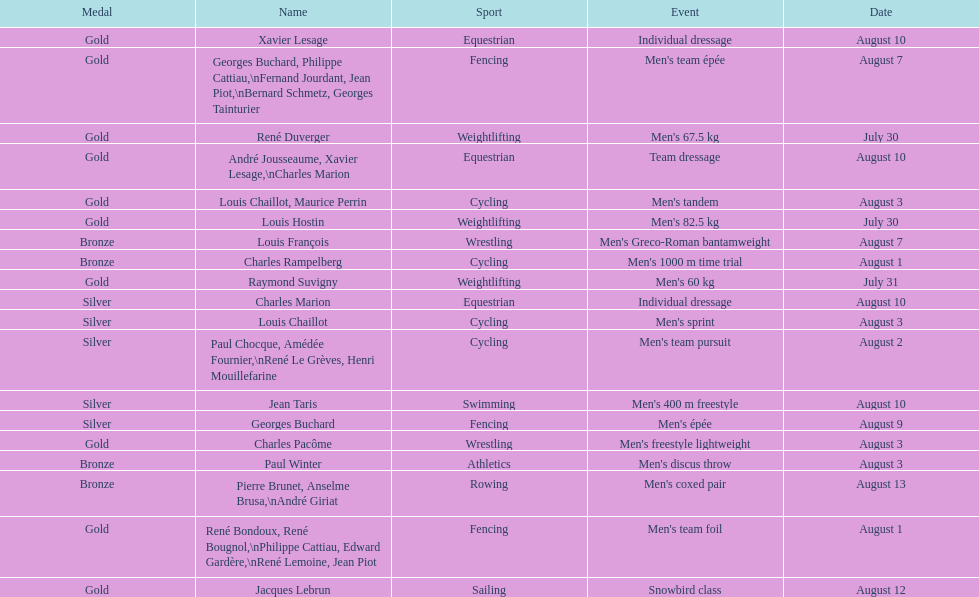Help me parse the entirety of this table. {'header': ['Medal', 'Name', 'Sport', 'Event', 'Date'], 'rows': [['Gold', 'Xavier Lesage', 'Equestrian', 'Individual dressage', 'August 10'], ['Gold', 'Georges Buchard, Philippe Cattiau,\\nFernand Jourdant, Jean Piot,\\nBernard Schmetz, Georges Tainturier', 'Fencing', "Men's team épée", 'August 7'], ['Gold', 'René Duverger', 'Weightlifting', "Men's 67.5 kg", 'July 30'], ['Gold', 'André Jousseaume, Xavier Lesage,\\nCharles Marion', 'Equestrian', 'Team dressage', 'August 10'], ['Gold', 'Louis Chaillot, Maurice Perrin', 'Cycling', "Men's tandem", 'August 3'], ['Gold', 'Louis Hostin', 'Weightlifting', "Men's 82.5 kg", 'July 30'], ['Bronze', 'Louis François', 'Wrestling', "Men's Greco-Roman bantamweight", 'August 7'], ['Bronze', 'Charles Rampelberg', 'Cycling', "Men's 1000 m time trial", 'August 1'], ['Gold', 'Raymond Suvigny', 'Weightlifting', "Men's 60 kg", 'July 31'], ['Silver', 'Charles Marion', 'Equestrian', 'Individual dressage', 'August 10'], ['Silver', 'Louis Chaillot', 'Cycling', "Men's sprint", 'August 3'], ['Silver', 'Paul Chocque, Amédée Fournier,\\nRené Le Grèves, Henri Mouillefarine', 'Cycling', "Men's team pursuit", 'August 2'], ['Silver', 'Jean Taris', 'Swimming', "Men's 400 m freestyle", 'August 10'], ['Silver', 'Georges Buchard', 'Fencing', "Men's épée", 'August 9'], ['Gold', 'Charles Pacôme', 'Wrestling', "Men's freestyle lightweight", 'August 3'], ['Bronze', 'Paul Winter', 'Athletics', "Men's discus throw", 'August 3'], ['Bronze', 'Pierre Brunet, Anselme Brusa,\\nAndré Giriat', 'Rowing', "Men's coxed pair", 'August 13'], ['Gold', 'René Bondoux, René Bougnol,\\nPhilippe Cattiau, Edward Gardère,\\nRené Lemoine, Jean Piot', 'Fencing', "Men's team foil", 'August 1'], ['Gold', 'Jacques Lebrun', 'Sailing', 'Snowbird class', 'August 12']]} What event is listed right before team dressage? Individual dressage. 